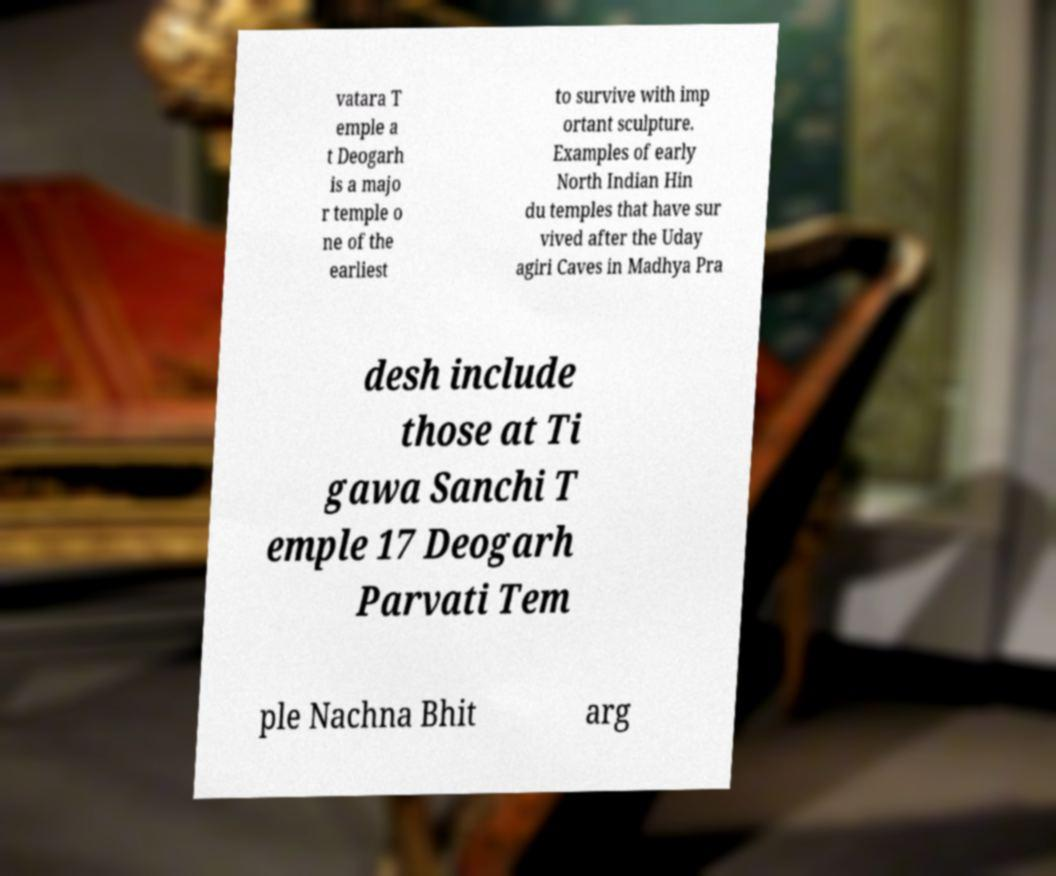Could you extract and type out the text from this image? vatara T emple a t Deogarh is a majo r temple o ne of the earliest to survive with imp ortant sculpture. Examples of early North Indian Hin du temples that have sur vived after the Uday agiri Caves in Madhya Pra desh include those at Ti gawa Sanchi T emple 17 Deogarh Parvati Tem ple Nachna Bhit arg 